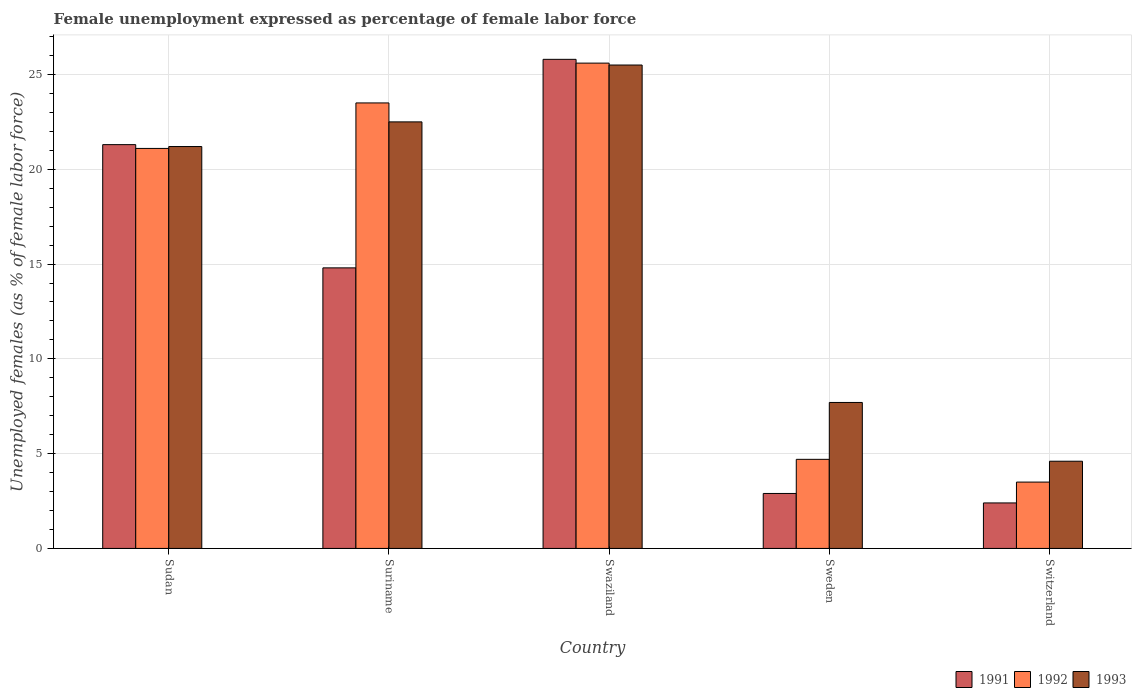How many bars are there on the 5th tick from the left?
Your answer should be compact. 3. What is the label of the 1st group of bars from the left?
Your response must be concise. Sudan. What is the unemployment in females in in 1992 in Swaziland?
Offer a very short reply. 25.6. Across all countries, what is the maximum unemployment in females in in 1991?
Offer a very short reply. 25.8. Across all countries, what is the minimum unemployment in females in in 1991?
Provide a short and direct response. 2.4. In which country was the unemployment in females in in 1992 maximum?
Give a very brief answer. Swaziland. In which country was the unemployment in females in in 1993 minimum?
Offer a very short reply. Switzerland. What is the total unemployment in females in in 1993 in the graph?
Your answer should be compact. 81.5. What is the difference between the unemployment in females in in 1992 in Switzerland and the unemployment in females in in 1993 in Sweden?
Offer a very short reply. -4.2. What is the average unemployment in females in in 1993 per country?
Your response must be concise. 16.3. What is the difference between the unemployment in females in of/in 1991 and unemployment in females in of/in 1992 in Sweden?
Ensure brevity in your answer.  -1.8. In how many countries, is the unemployment in females in in 1993 greater than 3 %?
Offer a very short reply. 5. What is the ratio of the unemployment in females in in 1993 in Suriname to that in Switzerland?
Provide a succinct answer. 4.89. Is the unemployment in females in in 1992 in Sudan less than that in Suriname?
Provide a short and direct response. Yes. What is the difference between the highest and the second highest unemployment in females in in 1993?
Provide a short and direct response. 4.3. What is the difference between the highest and the lowest unemployment in females in in 1992?
Offer a very short reply. 22.1. What does the 3rd bar from the left in Sweden represents?
Provide a succinct answer. 1993. What does the 2nd bar from the right in Sweden represents?
Provide a succinct answer. 1992. Is it the case that in every country, the sum of the unemployment in females in in 1993 and unemployment in females in in 1992 is greater than the unemployment in females in in 1991?
Offer a terse response. Yes. How many bars are there?
Your answer should be compact. 15. What is the difference between two consecutive major ticks on the Y-axis?
Your answer should be very brief. 5. Does the graph contain any zero values?
Your answer should be very brief. No. Does the graph contain grids?
Give a very brief answer. Yes. Where does the legend appear in the graph?
Make the answer very short. Bottom right. What is the title of the graph?
Your response must be concise. Female unemployment expressed as percentage of female labor force. Does "1996" appear as one of the legend labels in the graph?
Provide a short and direct response. No. What is the label or title of the X-axis?
Provide a short and direct response. Country. What is the label or title of the Y-axis?
Provide a succinct answer. Unemployed females (as % of female labor force). What is the Unemployed females (as % of female labor force) of 1991 in Sudan?
Your answer should be compact. 21.3. What is the Unemployed females (as % of female labor force) in 1992 in Sudan?
Keep it short and to the point. 21.1. What is the Unemployed females (as % of female labor force) in 1993 in Sudan?
Offer a very short reply. 21.2. What is the Unemployed females (as % of female labor force) in 1991 in Suriname?
Keep it short and to the point. 14.8. What is the Unemployed females (as % of female labor force) in 1992 in Suriname?
Make the answer very short. 23.5. What is the Unemployed females (as % of female labor force) in 1991 in Swaziland?
Your response must be concise. 25.8. What is the Unemployed females (as % of female labor force) in 1992 in Swaziland?
Make the answer very short. 25.6. What is the Unemployed females (as % of female labor force) of 1991 in Sweden?
Make the answer very short. 2.9. What is the Unemployed females (as % of female labor force) in 1992 in Sweden?
Your answer should be compact. 4.7. What is the Unemployed females (as % of female labor force) of 1993 in Sweden?
Offer a very short reply. 7.7. What is the Unemployed females (as % of female labor force) in 1991 in Switzerland?
Your answer should be very brief. 2.4. What is the Unemployed females (as % of female labor force) in 1992 in Switzerland?
Your answer should be very brief. 3.5. What is the Unemployed females (as % of female labor force) in 1993 in Switzerland?
Your answer should be compact. 4.6. Across all countries, what is the maximum Unemployed females (as % of female labor force) in 1991?
Ensure brevity in your answer.  25.8. Across all countries, what is the maximum Unemployed females (as % of female labor force) in 1992?
Keep it short and to the point. 25.6. Across all countries, what is the maximum Unemployed females (as % of female labor force) of 1993?
Your response must be concise. 25.5. Across all countries, what is the minimum Unemployed females (as % of female labor force) of 1991?
Offer a very short reply. 2.4. Across all countries, what is the minimum Unemployed females (as % of female labor force) in 1992?
Ensure brevity in your answer.  3.5. Across all countries, what is the minimum Unemployed females (as % of female labor force) of 1993?
Provide a short and direct response. 4.6. What is the total Unemployed females (as % of female labor force) of 1991 in the graph?
Keep it short and to the point. 67.2. What is the total Unemployed females (as % of female labor force) in 1992 in the graph?
Offer a very short reply. 78.4. What is the total Unemployed females (as % of female labor force) of 1993 in the graph?
Provide a succinct answer. 81.5. What is the difference between the Unemployed females (as % of female labor force) in 1991 in Sudan and that in Suriname?
Your answer should be very brief. 6.5. What is the difference between the Unemployed females (as % of female labor force) of 1991 in Sudan and that in Switzerland?
Your answer should be compact. 18.9. What is the difference between the Unemployed females (as % of female labor force) in 1992 in Sudan and that in Switzerland?
Provide a short and direct response. 17.6. What is the difference between the Unemployed females (as % of female labor force) of 1993 in Sudan and that in Switzerland?
Your response must be concise. 16.6. What is the difference between the Unemployed females (as % of female labor force) in 1991 in Suriname and that in Swaziland?
Offer a very short reply. -11. What is the difference between the Unemployed females (as % of female labor force) in 1991 in Suriname and that in Sweden?
Your response must be concise. 11.9. What is the difference between the Unemployed females (as % of female labor force) in 1993 in Suriname and that in Sweden?
Make the answer very short. 14.8. What is the difference between the Unemployed females (as % of female labor force) in 1992 in Suriname and that in Switzerland?
Ensure brevity in your answer.  20. What is the difference between the Unemployed females (as % of female labor force) of 1993 in Suriname and that in Switzerland?
Your answer should be very brief. 17.9. What is the difference between the Unemployed females (as % of female labor force) of 1991 in Swaziland and that in Sweden?
Your response must be concise. 22.9. What is the difference between the Unemployed females (as % of female labor force) in 1992 in Swaziland and that in Sweden?
Give a very brief answer. 20.9. What is the difference between the Unemployed females (as % of female labor force) of 1991 in Swaziland and that in Switzerland?
Offer a very short reply. 23.4. What is the difference between the Unemployed females (as % of female labor force) of 1992 in Swaziland and that in Switzerland?
Ensure brevity in your answer.  22.1. What is the difference between the Unemployed females (as % of female labor force) of 1993 in Swaziland and that in Switzerland?
Provide a succinct answer. 20.9. What is the difference between the Unemployed females (as % of female labor force) in 1991 in Sweden and that in Switzerland?
Make the answer very short. 0.5. What is the difference between the Unemployed females (as % of female labor force) of 1992 in Sweden and that in Switzerland?
Give a very brief answer. 1.2. What is the difference between the Unemployed females (as % of female labor force) of 1993 in Sweden and that in Switzerland?
Keep it short and to the point. 3.1. What is the difference between the Unemployed females (as % of female labor force) of 1991 in Sudan and the Unemployed females (as % of female labor force) of 1993 in Swaziland?
Make the answer very short. -4.2. What is the difference between the Unemployed females (as % of female labor force) in 1992 in Sudan and the Unemployed females (as % of female labor force) in 1993 in Swaziland?
Offer a very short reply. -4.4. What is the difference between the Unemployed females (as % of female labor force) in 1991 in Sudan and the Unemployed females (as % of female labor force) in 1992 in Sweden?
Ensure brevity in your answer.  16.6. What is the difference between the Unemployed females (as % of female labor force) of 1991 in Sudan and the Unemployed females (as % of female labor force) of 1993 in Sweden?
Provide a short and direct response. 13.6. What is the difference between the Unemployed females (as % of female labor force) of 1992 in Sudan and the Unemployed females (as % of female labor force) of 1993 in Sweden?
Your response must be concise. 13.4. What is the difference between the Unemployed females (as % of female labor force) in 1991 in Sudan and the Unemployed females (as % of female labor force) in 1993 in Switzerland?
Make the answer very short. 16.7. What is the difference between the Unemployed females (as % of female labor force) of 1992 in Sudan and the Unemployed females (as % of female labor force) of 1993 in Switzerland?
Your answer should be compact. 16.5. What is the difference between the Unemployed females (as % of female labor force) of 1991 in Suriname and the Unemployed females (as % of female labor force) of 1992 in Swaziland?
Your answer should be very brief. -10.8. What is the difference between the Unemployed females (as % of female labor force) in 1991 in Suriname and the Unemployed females (as % of female labor force) in 1992 in Sweden?
Your answer should be very brief. 10.1. What is the difference between the Unemployed females (as % of female labor force) of 1991 in Suriname and the Unemployed females (as % of female labor force) of 1993 in Sweden?
Make the answer very short. 7.1. What is the difference between the Unemployed females (as % of female labor force) in 1991 in Suriname and the Unemployed females (as % of female labor force) in 1992 in Switzerland?
Make the answer very short. 11.3. What is the difference between the Unemployed females (as % of female labor force) in 1991 in Swaziland and the Unemployed females (as % of female labor force) in 1992 in Sweden?
Make the answer very short. 21.1. What is the difference between the Unemployed females (as % of female labor force) of 1991 in Swaziland and the Unemployed females (as % of female labor force) of 1993 in Sweden?
Offer a very short reply. 18.1. What is the difference between the Unemployed females (as % of female labor force) of 1992 in Swaziland and the Unemployed females (as % of female labor force) of 1993 in Sweden?
Keep it short and to the point. 17.9. What is the difference between the Unemployed females (as % of female labor force) in 1991 in Swaziland and the Unemployed females (as % of female labor force) in 1992 in Switzerland?
Ensure brevity in your answer.  22.3. What is the difference between the Unemployed females (as % of female labor force) in 1991 in Swaziland and the Unemployed females (as % of female labor force) in 1993 in Switzerland?
Keep it short and to the point. 21.2. What is the difference between the Unemployed females (as % of female labor force) in 1992 in Swaziland and the Unemployed females (as % of female labor force) in 1993 in Switzerland?
Your answer should be very brief. 21. What is the difference between the Unemployed females (as % of female labor force) in 1991 in Sweden and the Unemployed females (as % of female labor force) in 1992 in Switzerland?
Your answer should be compact. -0.6. What is the difference between the Unemployed females (as % of female labor force) in 1992 in Sweden and the Unemployed females (as % of female labor force) in 1993 in Switzerland?
Keep it short and to the point. 0.1. What is the average Unemployed females (as % of female labor force) in 1991 per country?
Offer a very short reply. 13.44. What is the average Unemployed females (as % of female labor force) in 1992 per country?
Offer a very short reply. 15.68. What is the average Unemployed females (as % of female labor force) in 1993 per country?
Ensure brevity in your answer.  16.3. What is the difference between the Unemployed females (as % of female labor force) in 1991 and Unemployed females (as % of female labor force) in 1992 in Suriname?
Provide a succinct answer. -8.7. What is the difference between the Unemployed females (as % of female labor force) of 1991 and Unemployed females (as % of female labor force) of 1993 in Swaziland?
Ensure brevity in your answer.  0.3. What is the difference between the Unemployed females (as % of female labor force) in 1991 and Unemployed females (as % of female labor force) in 1993 in Sweden?
Your response must be concise. -4.8. What is the difference between the Unemployed females (as % of female labor force) of 1992 and Unemployed females (as % of female labor force) of 1993 in Sweden?
Give a very brief answer. -3. What is the difference between the Unemployed females (as % of female labor force) of 1991 and Unemployed females (as % of female labor force) of 1992 in Switzerland?
Your answer should be very brief. -1.1. What is the difference between the Unemployed females (as % of female labor force) in 1991 and Unemployed females (as % of female labor force) in 1993 in Switzerland?
Your answer should be compact. -2.2. What is the difference between the Unemployed females (as % of female labor force) of 1992 and Unemployed females (as % of female labor force) of 1993 in Switzerland?
Your answer should be very brief. -1.1. What is the ratio of the Unemployed females (as % of female labor force) in 1991 in Sudan to that in Suriname?
Your answer should be compact. 1.44. What is the ratio of the Unemployed females (as % of female labor force) in 1992 in Sudan to that in Suriname?
Give a very brief answer. 0.9. What is the ratio of the Unemployed females (as % of female labor force) in 1993 in Sudan to that in Suriname?
Make the answer very short. 0.94. What is the ratio of the Unemployed females (as % of female labor force) in 1991 in Sudan to that in Swaziland?
Give a very brief answer. 0.83. What is the ratio of the Unemployed females (as % of female labor force) of 1992 in Sudan to that in Swaziland?
Provide a short and direct response. 0.82. What is the ratio of the Unemployed females (as % of female labor force) of 1993 in Sudan to that in Swaziland?
Offer a terse response. 0.83. What is the ratio of the Unemployed females (as % of female labor force) in 1991 in Sudan to that in Sweden?
Give a very brief answer. 7.34. What is the ratio of the Unemployed females (as % of female labor force) of 1992 in Sudan to that in Sweden?
Your response must be concise. 4.49. What is the ratio of the Unemployed females (as % of female labor force) in 1993 in Sudan to that in Sweden?
Offer a terse response. 2.75. What is the ratio of the Unemployed females (as % of female labor force) in 1991 in Sudan to that in Switzerland?
Your answer should be very brief. 8.88. What is the ratio of the Unemployed females (as % of female labor force) of 1992 in Sudan to that in Switzerland?
Give a very brief answer. 6.03. What is the ratio of the Unemployed females (as % of female labor force) of 1993 in Sudan to that in Switzerland?
Keep it short and to the point. 4.61. What is the ratio of the Unemployed females (as % of female labor force) in 1991 in Suriname to that in Swaziland?
Your response must be concise. 0.57. What is the ratio of the Unemployed females (as % of female labor force) in 1992 in Suriname to that in Swaziland?
Offer a terse response. 0.92. What is the ratio of the Unemployed females (as % of female labor force) of 1993 in Suriname to that in Swaziland?
Your response must be concise. 0.88. What is the ratio of the Unemployed females (as % of female labor force) in 1991 in Suriname to that in Sweden?
Keep it short and to the point. 5.1. What is the ratio of the Unemployed females (as % of female labor force) of 1992 in Suriname to that in Sweden?
Offer a very short reply. 5. What is the ratio of the Unemployed females (as % of female labor force) in 1993 in Suriname to that in Sweden?
Provide a short and direct response. 2.92. What is the ratio of the Unemployed females (as % of female labor force) of 1991 in Suriname to that in Switzerland?
Your response must be concise. 6.17. What is the ratio of the Unemployed females (as % of female labor force) in 1992 in Suriname to that in Switzerland?
Give a very brief answer. 6.71. What is the ratio of the Unemployed females (as % of female labor force) in 1993 in Suriname to that in Switzerland?
Keep it short and to the point. 4.89. What is the ratio of the Unemployed females (as % of female labor force) in 1991 in Swaziland to that in Sweden?
Provide a succinct answer. 8.9. What is the ratio of the Unemployed females (as % of female labor force) in 1992 in Swaziland to that in Sweden?
Offer a very short reply. 5.45. What is the ratio of the Unemployed females (as % of female labor force) of 1993 in Swaziland to that in Sweden?
Make the answer very short. 3.31. What is the ratio of the Unemployed females (as % of female labor force) in 1991 in Swaziland to that in Switzerland?
Keep it short and to the point. 10.75. What is the ratio of the Unemployed females (as % of female labor force) of 1992 in Swaziland to that in Switzerland?
Offer a terse response. 7.31. What is the ratio of the Unemployed females (as % of female labor force) of 1993 in Swaziland to that in Switzerland?
Provide a succinct answer. 5.54. What is the ratio of the Unemployed females (as % of female labor force) in 1991 in Sweden to that in Switzerland?
Your answer should be very brief. 1.21. What is the ratio of the Unemployed females (as % of female labor force) of 1992 in Sweden to that in Switzerland?
Provide a short and direct response. 1.34. What is the ratio of the Unemployed females (as % of female labor force) in 1993 in Sweden to that in Switzerland?
Your response must be concise. 1.67. What is the difference between the highest and the second highest Unemployed females (as % of female labor force) in 1992?
Your answer should be compact. 2.1. What is the difference between the highest and the second highest Unemployed females (as % of female labor force) in 1993?
Make the answer very short. 3. What is the difference between the highest and the lowest Unemployed females (as % of female labor force) of 1991?
Offer a very short reply. 23.4. What is the difference between the highest and the lowest Unemployed females (as % of female labor force) of 1992?
Offer a terse response. 22.1. What is the difference between the highest and the lowest Unemployed females (as % of female labor force) in 1993?
Provide a short and direct response. 20.9. 